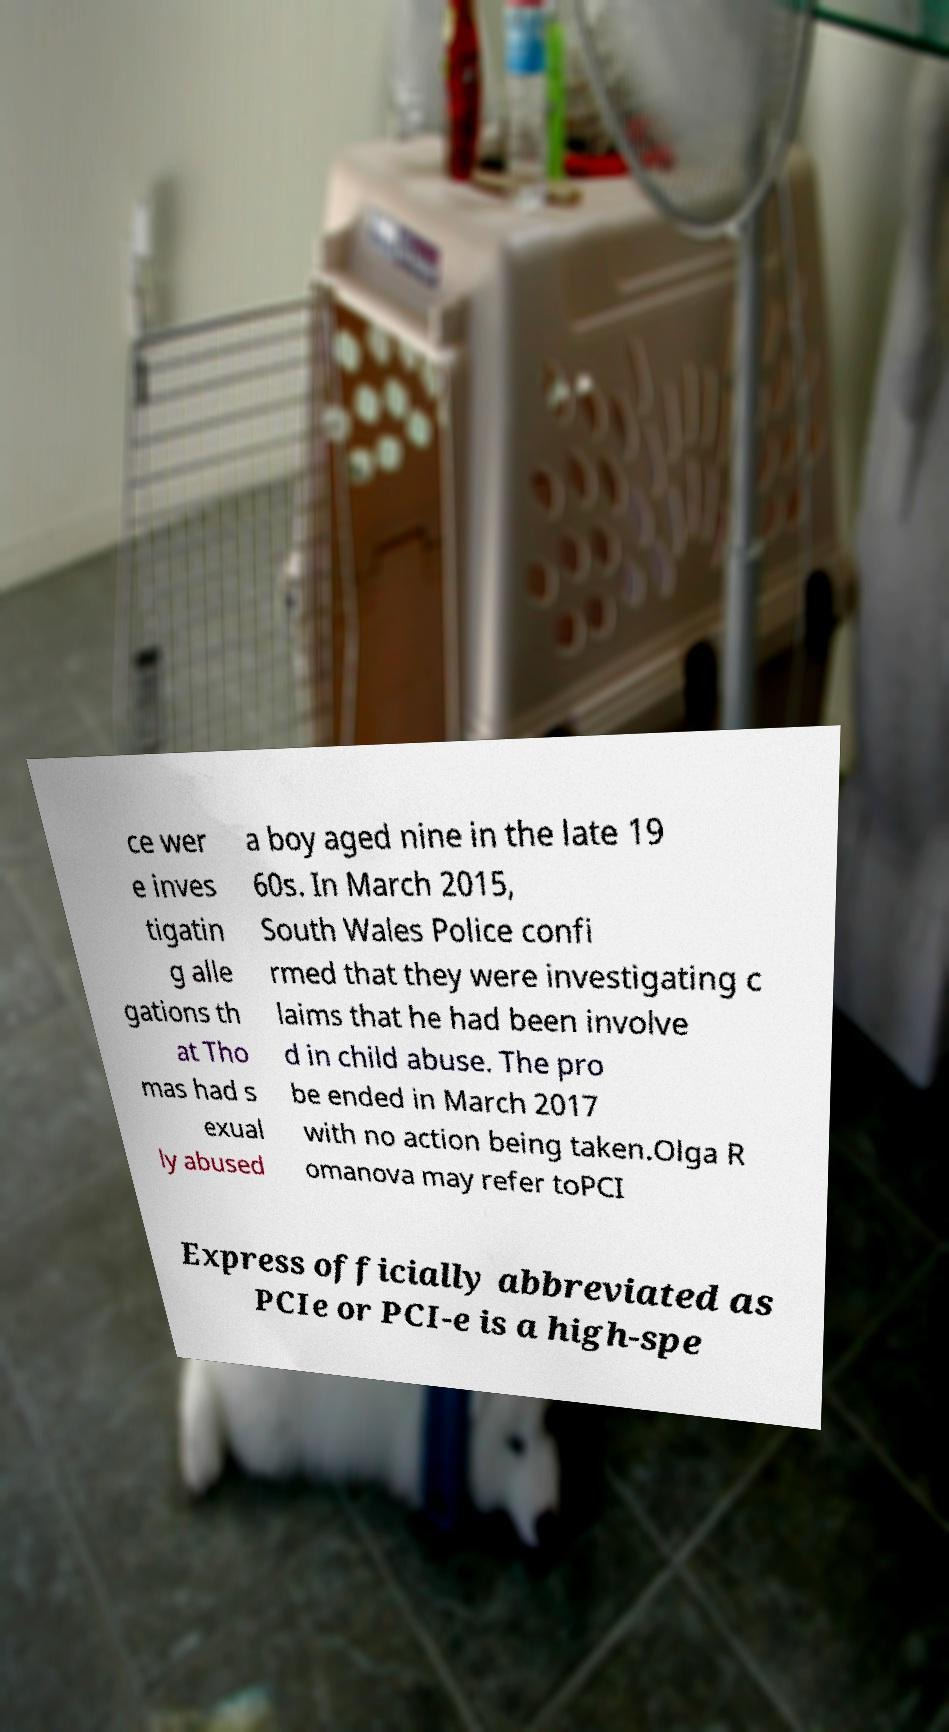Please read and relay the text visible in this image. What does it say? ce wer e inves tigatin g alle gations th at Tho mas had s exual ly abused a boy aged nine in the late 19 60s. In March 2015, South Wales Police confi rmed that they were investigating c laims that he had been involve d in child abuse. The pro be ended in March 2017 with no action being taken.Olga R omanova may refer toPCI Express officially abbreviated as PCIe or PCI-e is a high-spe 